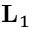<formula> <loc_0><loc_0><loc_500><loc_500>L _ { 1 }</formula> 